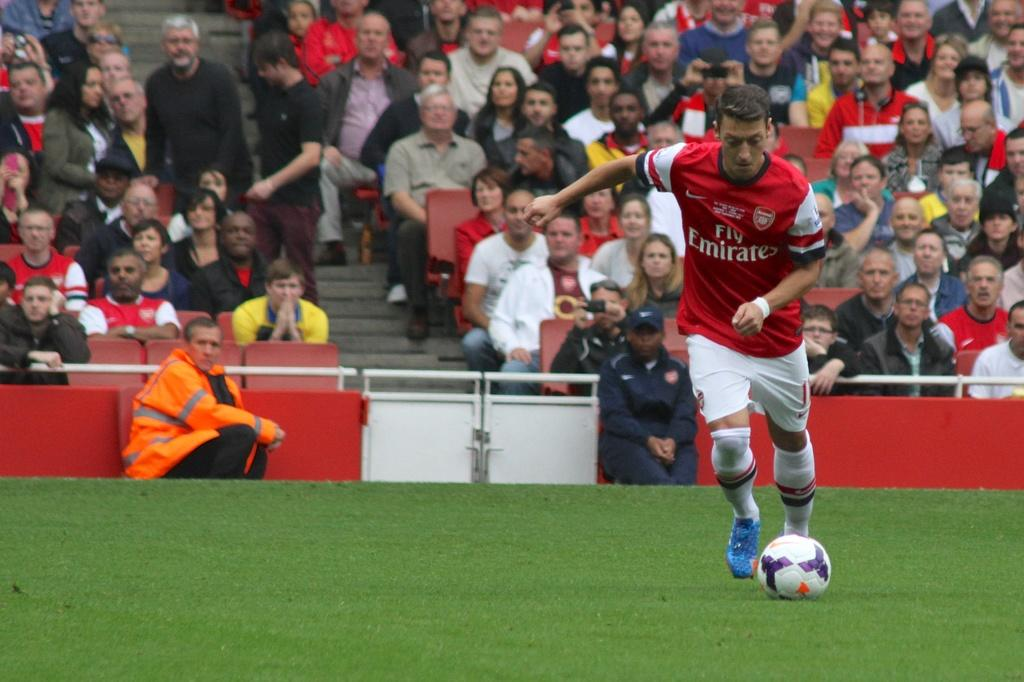<image>
Present a compact description of the photo's key features. a man wearing a soccer jersey that says 'fly emirates' on it 